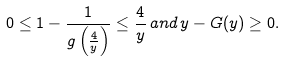<formula> <loc_0><loc_0><loc_500><loc_500>0 \leq 1 - \frac { 1 } { g \left ( \frac { 4 } { y } \right ) } \leq \frac { 4 } { y } \, a n d \, y - G ( y ) \geq 0 .</formula> 